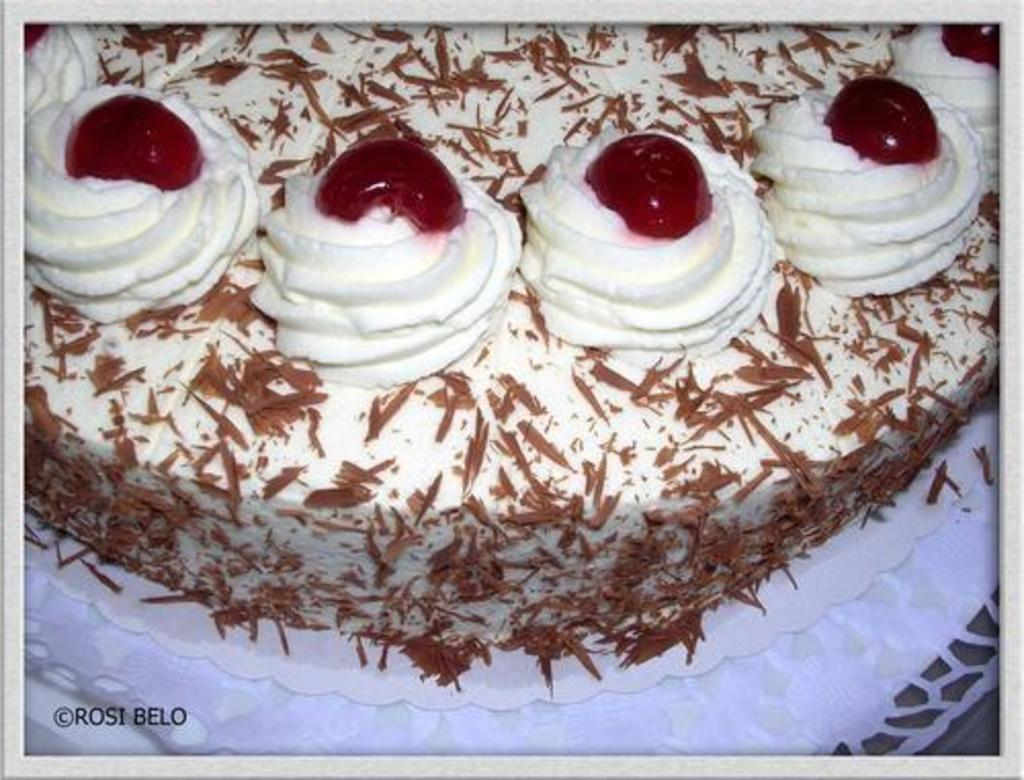What is the main subject of the image? There is a cake in the image. Can you describe the colors of the cake? The cake has white, brown, and red colors. How many spots can be seen on the flag in the image? There is no flag present in the image, so it is not possible to determine the number of spots on it. 